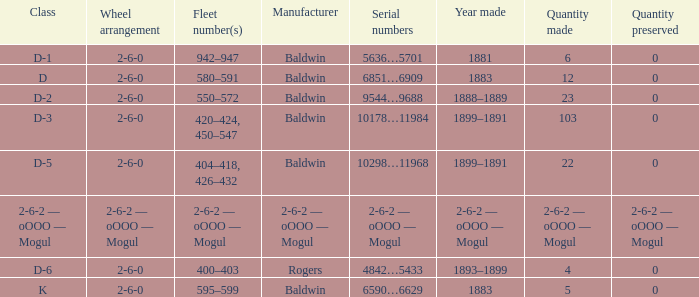What is the class when the quantity perserved is 0 and the quantity made is 5? K. 